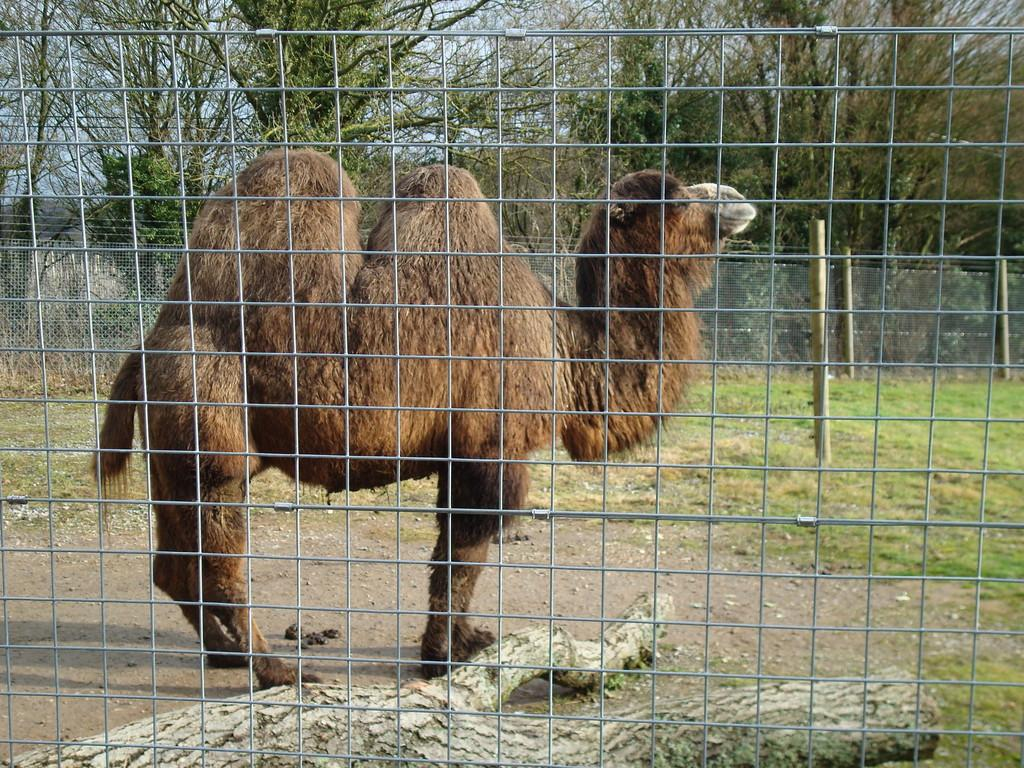What natural element can be seen in the image? There is a branch visible in the image. What type of living creature is present in the image? There is an animal in the image. What type of vegetation is present in the image? There is grass in the image. What type of plant life is present in the image? There are trees in the image. What type of barrier is present in the image? There is a mesh fence in the image. What type of grape is being used as a toy by the animal in the image? There is no grape present in the image, and the animal is not using any object as a toy. How many chickens are visible in the image? There is no chicken present in the image. What type of container is being used to hold water for the animal in the image? There is no container present in the image, and no water is being held for the animal. 